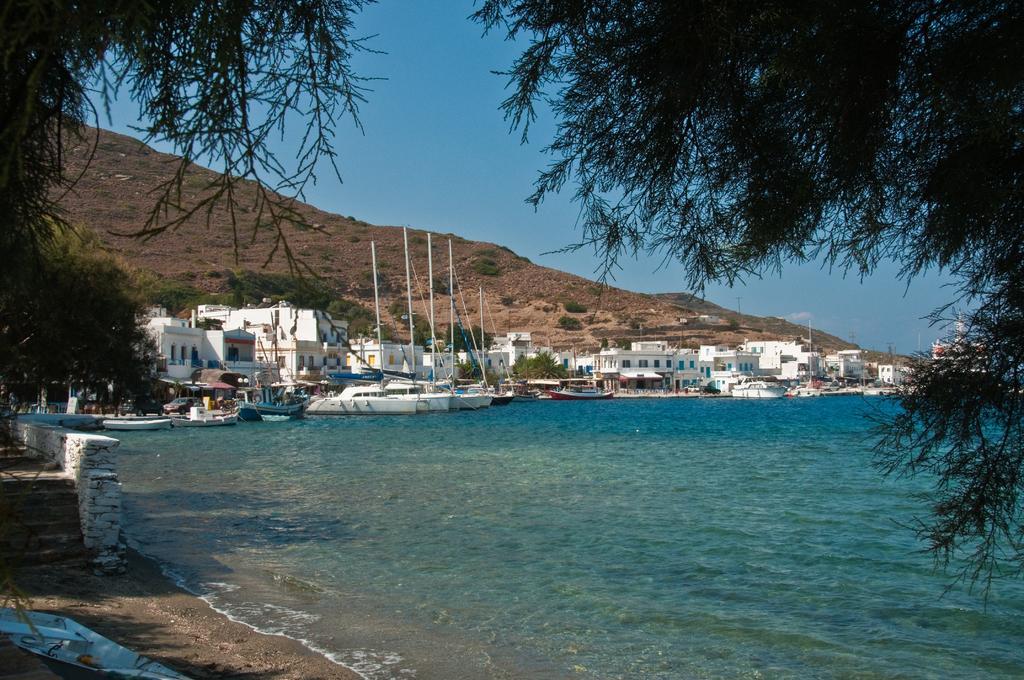Please provide a concise description of this image. In this image I can see few boats in water, they are in white color and the water is in blue color. At back I can see few building in white color, trees in green color and sky in blue color. 